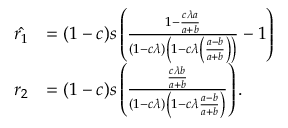<formula> <loc_0><loc_0><loc_500><loc_500>\begin{array} { r l } { \hat { r _ { 1 } } } & { = ( 1 - c ) s \left ( \frac { 1 - \frac { c \lambda a } { a + b } } { ( 1 - c \lambda ) \left ( 1 - c \lambda \left ( \frac { a - b } { a + b } \right ) \right ) } - 1 \right ) } \\ { r _ { 2 } } & { = ( 1 - c ) s \left ( \frac { \frac { c \lambda b } { a + b } } { ( 1 - c \lambda ) \left ( 1 - c \lambda \frac { a - b } { a + b } \right ) } \right ) . } \end{array}</formula> 